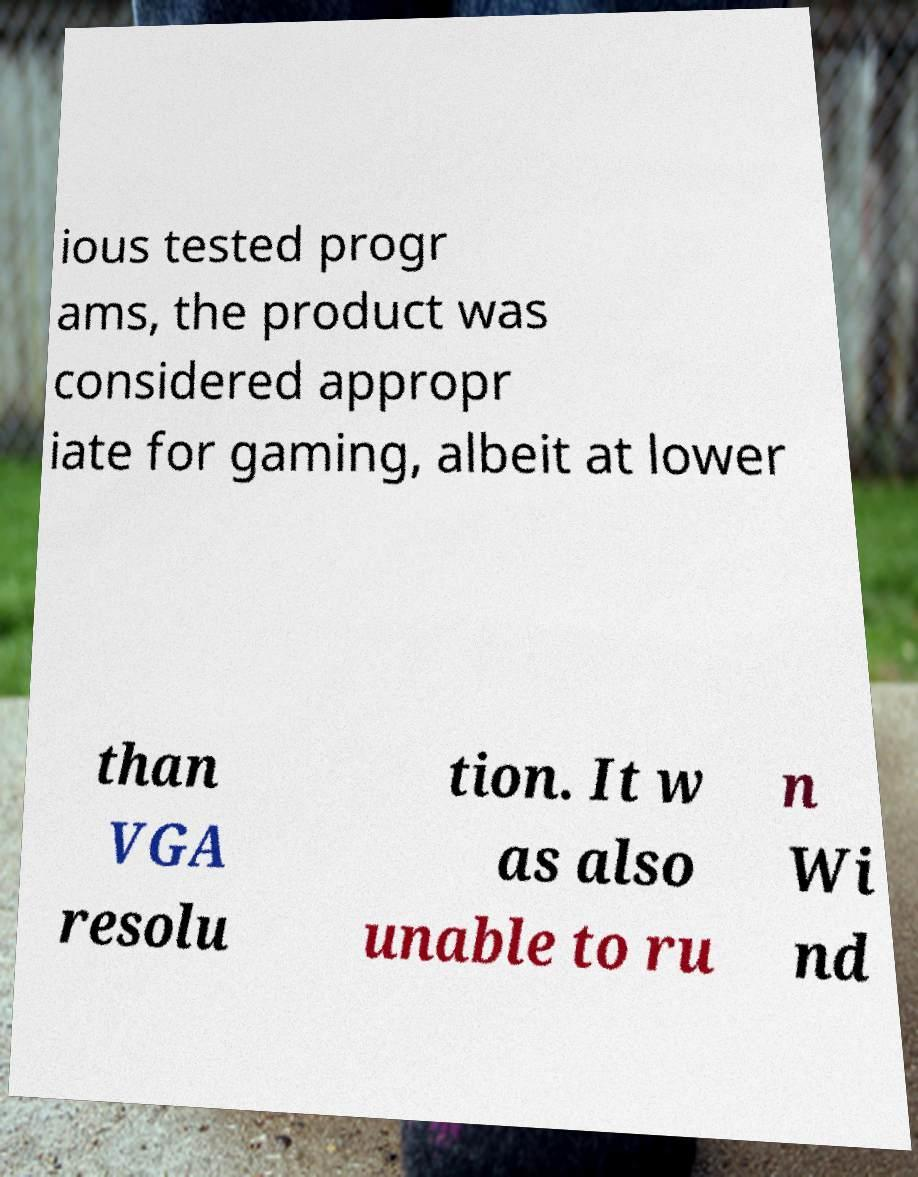There's text embedded in this image that I need extracted. Can you transcribe it verbatim? ious tested progr ams, the product was considered appropr iate for gaming, albeit at lower than VGA resolu tion. It w as also unable to ru n Wi nd 